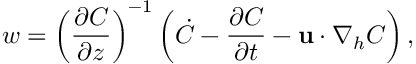Convert formula to latex. <formula><loc_0><loc_0><loc_500><loc_500>w = \left ( \frac { \partial C } { \partial z } \right ) ^ { - 1 } \left ( \dot { C } - \frac { \partial C } { \partial t } - { u } \cdot \nabla _ { h } C \right ) ,</formula> 